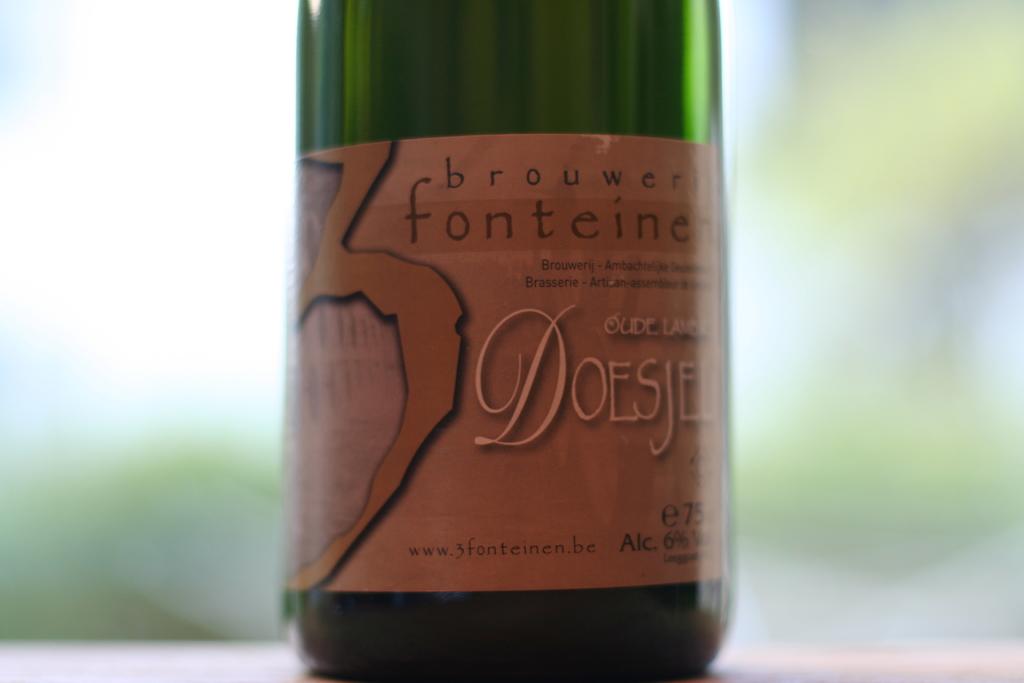What brand is featured?
Provide a succinct answer. Brouwer fonteine. 